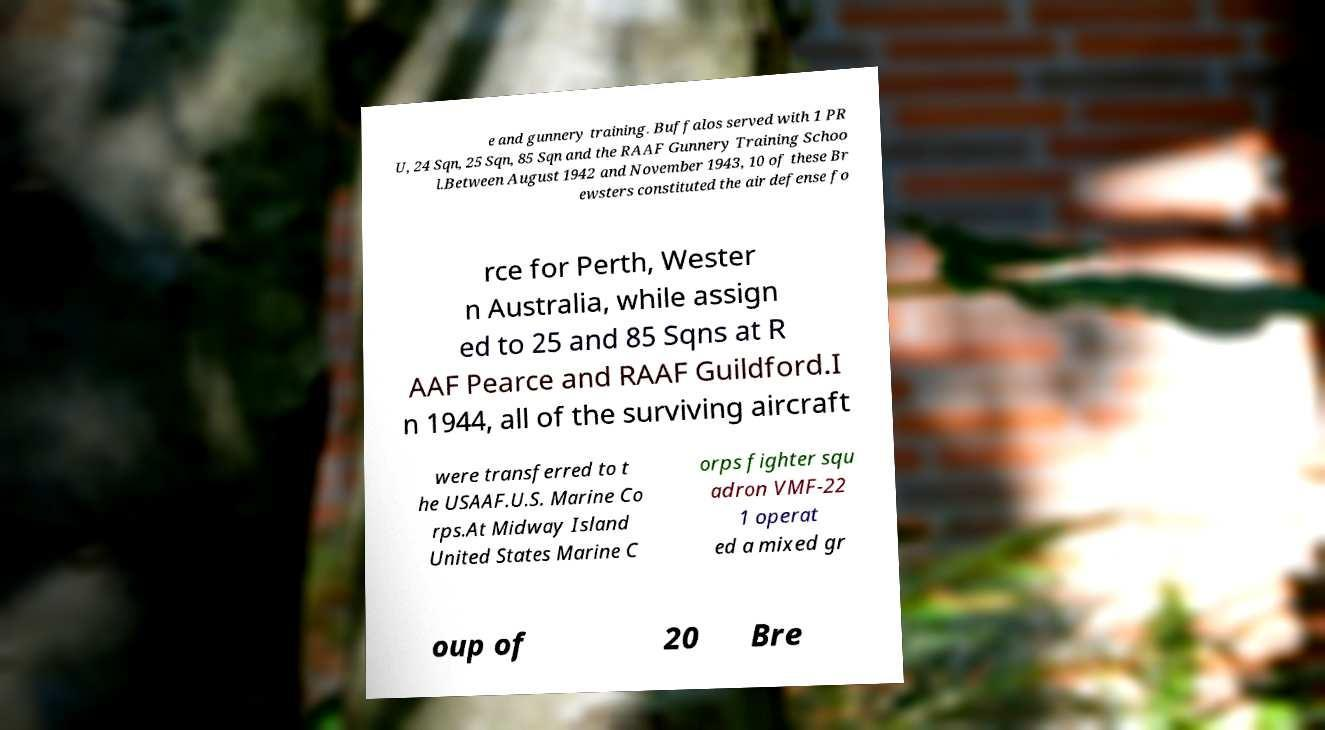For documentation purposes, I need the text within this image transcribed. Could you provide that? e and gunnery training. Buffalos served with 1 PR U, 24 Sqn, 25 Sqn, 85 Sqn and the RAAF Gunnery Training Schoo l.Between August 1942 and November 1943, 10 of these Br ewsters constituted the air defense fo rce for Perth, Wester n Australia, while assign ed to 25 and 85 Sqns at R AAF Pearce and RAAF Guildford.I n 1944, all of the surviving aircraft were transferred to t he USAAF.U.S. Marine Co rps.At Midway Island United States Marine C orps fighter squ adron VMF-22 1 operat ed a mixed gr oup of 20 Bre 